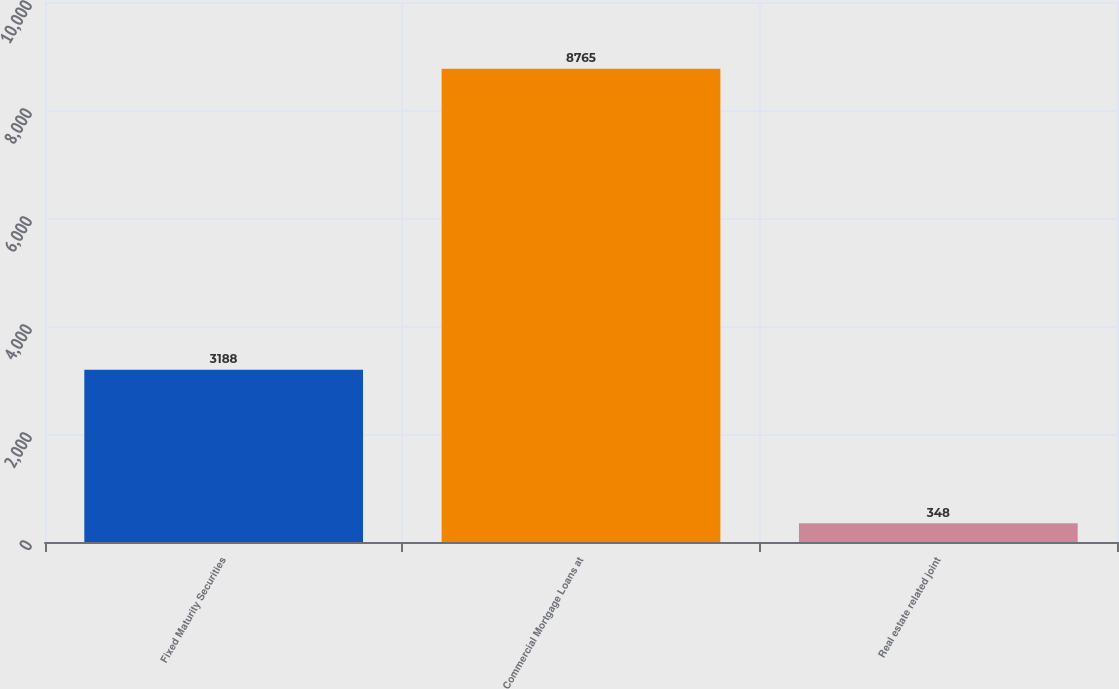<chart> <loc_0><loc_0><loc_500><loc_500><bar_chart><fcel>Fixed Maturity Securities<fcel>Commercial Mortgage Loans at<fcel>Real estate related joint<nl><fcel>3188<fcel>8765<fcel>348<nl></chart> 